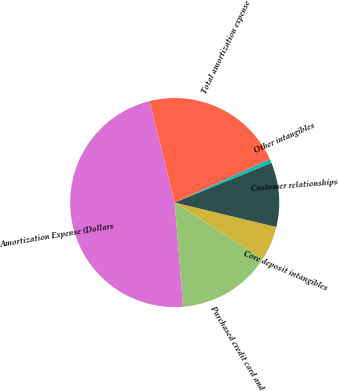<chart> <loc_0><loc_0><loc_500><loc_500><pie_chart><fcel>Amortization Expense (Dollars<fcel>Purchased credit card and<fcel>Core deposit intangibles<fcel>Customer relationships<fcel>Other intangibles<fcel>Total amortization expense<nl><fcel>47.42%<fcel>14.66%<fcel>5.29%<fcel>9.97%<fcel>0.61%<fcel>22.04%<nl></chart> 